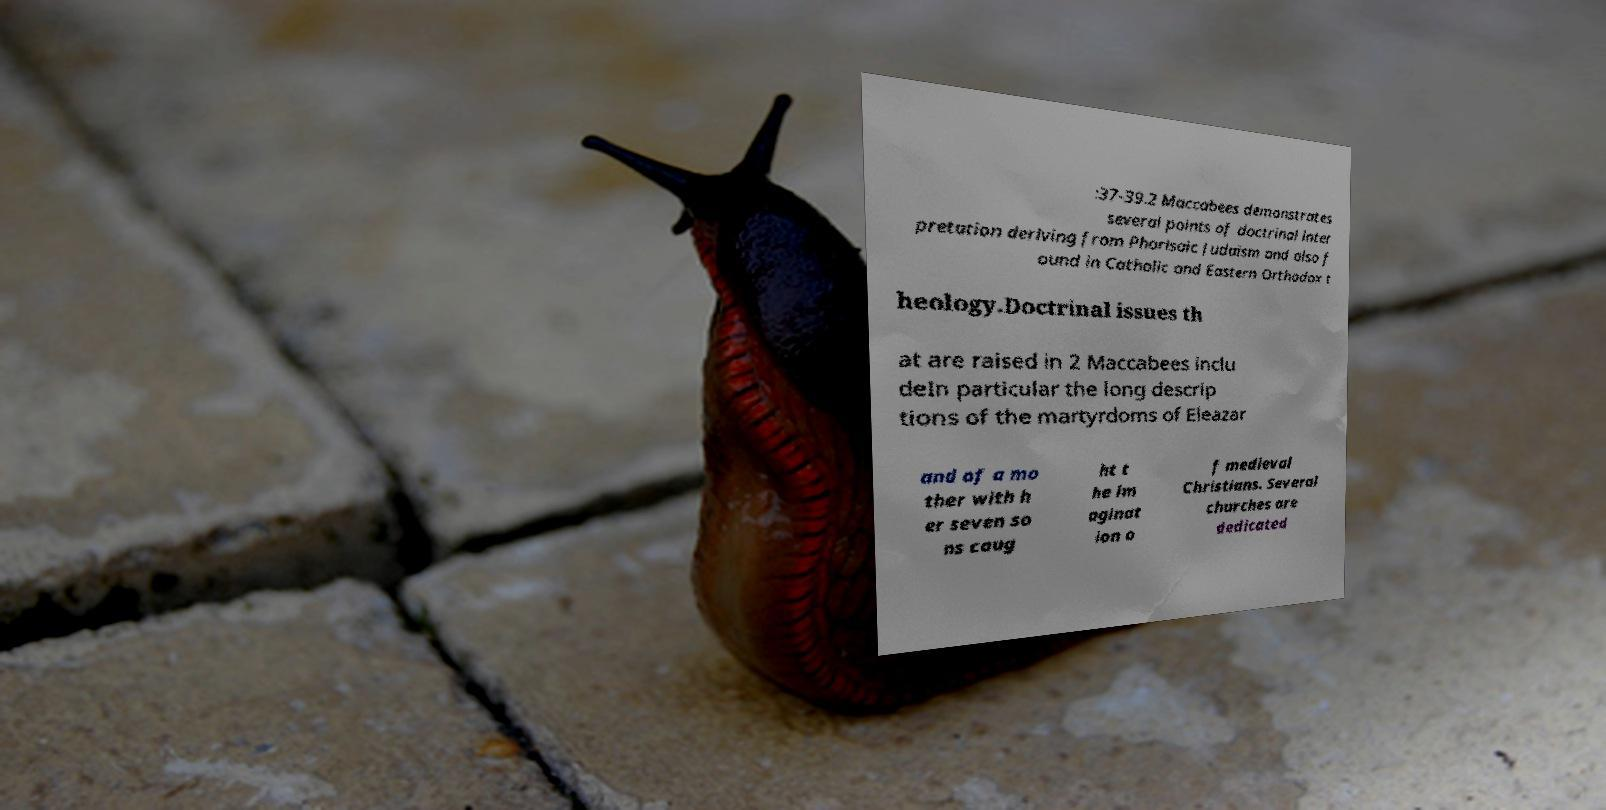There's text embedded in this image that I need extracted. Can you transcribe it verbatim? :37-39.2 Maccabees demonstrates several points of doctrinal inter pretation deriving from Pharisaic Judaism and also f ound in Catholic and Eastern Orthodox t heology.Doctrinal issues th at are raised in 2 Maccabees inclu deIn particular the long descrip tions of the martyrdoms of Eleazar and of a mo ther with h er seven so ns caug ht t he im aginat ion o f medieval Christians. Several churches are dedicated 